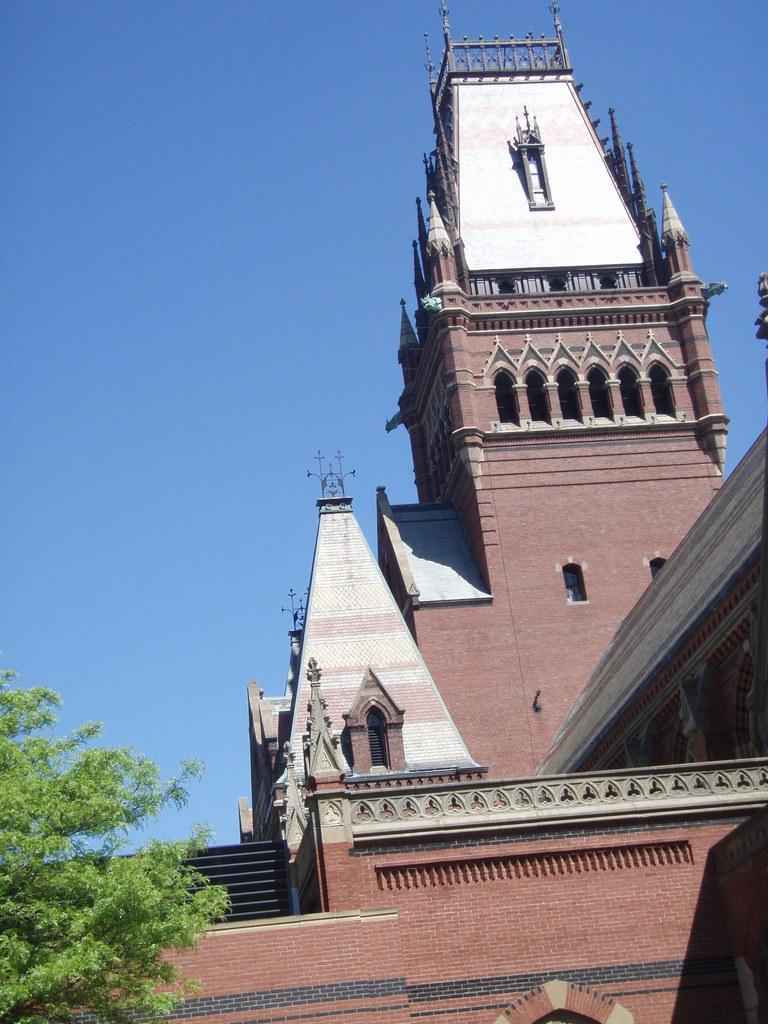Where was the picture taken? The picture was clicked outside. What can be seen on the right side of the image? There is a building on the right side of the image. What is located on the left side of the image? There is a tree on the left side of the image. What is visible in the background of the image? The sky is visible in the background of the image. How many sacks are hanging from the tree in the image? There are no sacks present in the image; it features a tree and a building. Can you see any snakes slithering around the building in the image? There are no snakes visible in the image; it only shows a tree, a building, and the sky. 